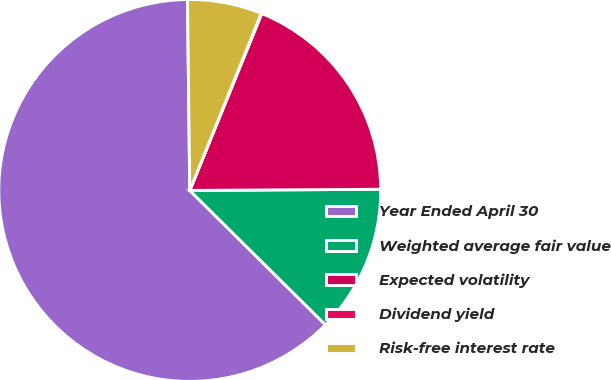Convert chart to OTSL. <chart><loc_0><loc_0><loc_500><loc_500><pie_chart><fcel>Year Ended April 30<fcel>Weighted average fair value<fcel>Expected volatility<fcel>Dividend yield<fcel>Risk-free interest rate<nl><fcel>62.39%<fcel>12.52%<fcel>18.75%<fcel>0.05%<fcel>6.29%<nl></chart> 